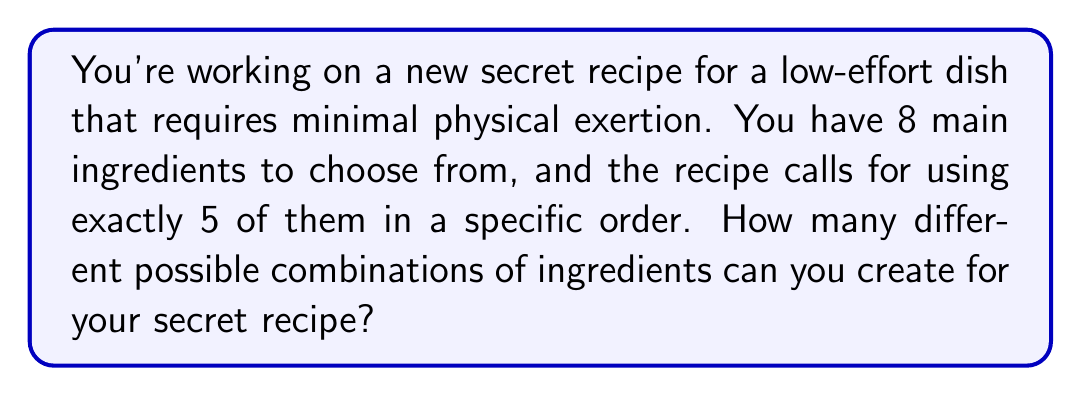Solve this math problem. Let's approach this step-by-step:

1) This is a permutation problem. We are selecting 5 ingredients out of 8, and the order matters (as specified in the question).

2) The formula for permutations is:

   $$P(n,r) = \frac{n!}{(n-r)!}$$

   Where $n$ is the total number of items to choose from, and $r$ is the number of items being chosen.

3) In this case, $n = 8$ (total ingredients) and $r = 5$ (ingredients used in the recipe).

4) Let's substitute these values into our formula:

   $$P(8,5) = \frac{8!}{(8-5)!} = \frac{8!}{3!}$$

5) Now, let's calculate this:
   
   $$\frac{8!}{3!} = \frac{8 \times 7 \times 6 \times 5 \times 4 \times 3!}{3!}$$

6) The $3!$ cancels out in the numerator and denominator:

   $$8 \times 7 \times 6 \times 5 \times 4 = 6720$$

Therefore, there are 6720 different possible combinations for your secret recipe.
Answer: 6720 